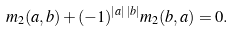Convert formula to latex. <formula><loc_0><loc_0><loc_500><loc_500>m _ { 2 } ( a , b ) + ( - 1 ) ^ { | a | \, | b | } m _ { 2 } ( b , a ) = 0 .</formula> 